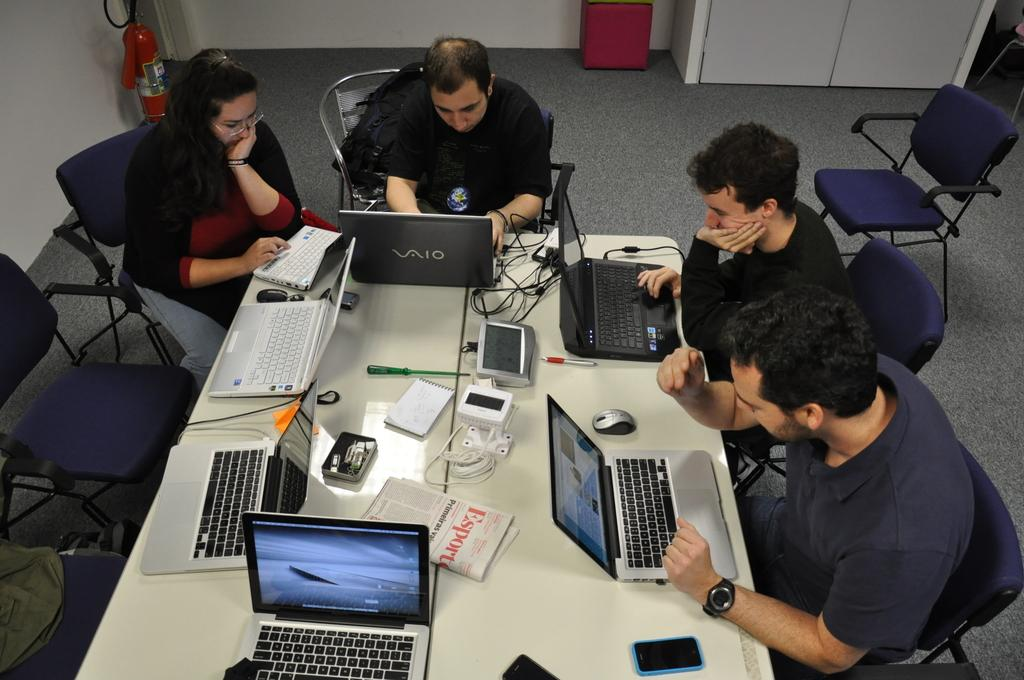<image>
Share a concise interpretation of the image provided. Four people collaborate inside a conference room including one typing on a VAIO laptop. 